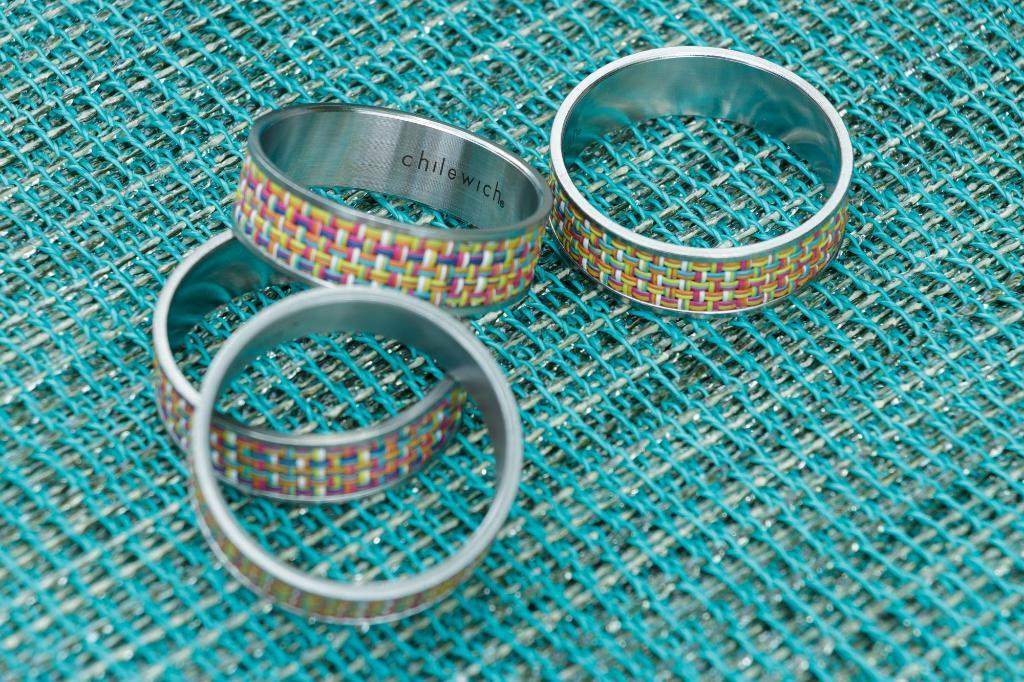How many finger rings are visible in the image? There are four finger rings in the image. What is the finger rings placed on? The finger rings are placed on a mesh. What type of authority figure is wearing the veil in the image? There is no authority figure or veil present in the image; it only features four finger rings placed on a mesh. 